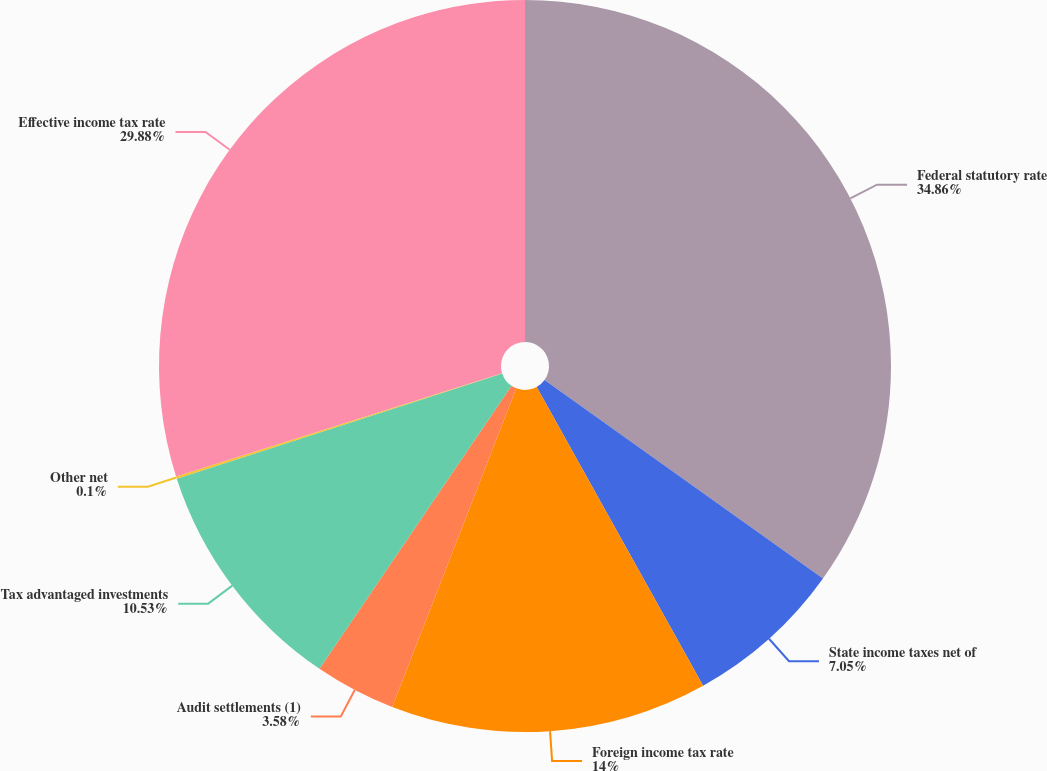Convert chart. <chart><loc_0><loc_0><loc_500><loc_500><pie_chart><fcel>Federal statutory rate<fcel>State income taxes net of<fcel>Foreign income tax rate<fcel>Audit settlements (1)<fcel>Tax advantaged investments<fcel>Other net<fcel>Effective income tax rate<nl><fcel>34.86%<fcel>7.05%<fcel>14.0%<fcel>3.58%<fcel>10.53%<fcel>0.1%<fcel>29.88%<nl></chart> 